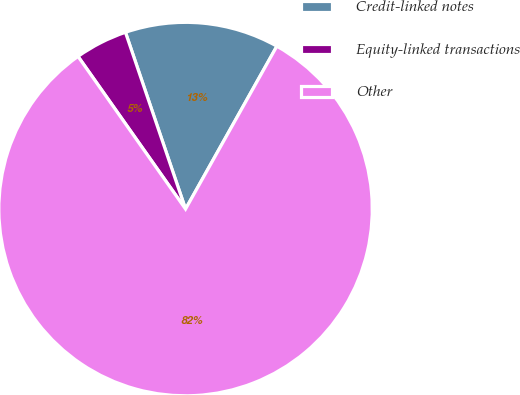Convert chart to OTSL. <chart><loc_0><loc_0><loc_500><loc_500><pie_chart><fcel>Credit-linked notes<fcel>Equity-linked transactions<fcel>Other<nl><fcel>13.35%<fcel>4.55%<fcel>82.1%<nl></chart> 